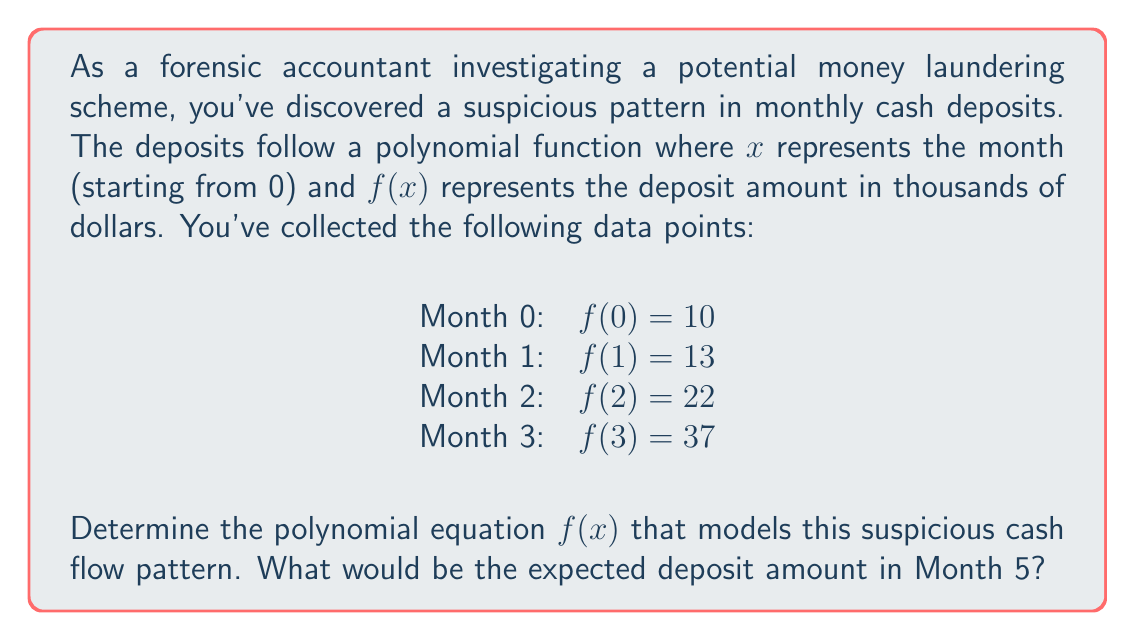Can you solve this math problem? To solve this problem, we'll use the method of finite differences to determine the degree of the polynomial and then solve for its coefficients.

Step 1: Calculate the first, second, and third differences:
First differences:
$13 - 10 = 3$
$22 - 13 = 9$
$37 - 22 = 15$

Second differences:
$9 - 3 = 6$
$15 - 9 = 6$

Third differences:
$6 - 6 = 0$

Since the third difference is constant (0), we have a cubic polynomial of the form:
$f(x) = ax^3 + bx^2 + cx + d$

Step 2: Set up a system of equations using the given data points:
$f(0) = d = 10$
$f(1) = a + b + c + d = 13$
$f(2) = 8a + 4b + 2c + d = 22$
$f(3) = 27a + 9b + 3c + d = 37$

Step 3: Solve the system of equations:
$d = 10$
$a + b + c = 3$
$8a + 4b + 2c = 12$
$27a + 9b + 3c = 27$

Subtracting equations and solving:
$c = 0$
$b = 6$
$a = -3$

Step 4: Write the polynomial equation:
$f(x) = -3x^3 + 6x^2 + 10$

Step 5: Calculate the expected deposit amount for Month 5:
$f(5) = -3(5^3) + 6(5^2) + 10$
$f(5) = -375 + 150 + 10 = -215$

The negative value indicates an unexpected withdrawal, which could be a red flag in the investigation.
Answer: $f(x) = -3x^3 + 6x^2 + 10$; Expected deposit in Month 5: $-215$ thousand dollars 